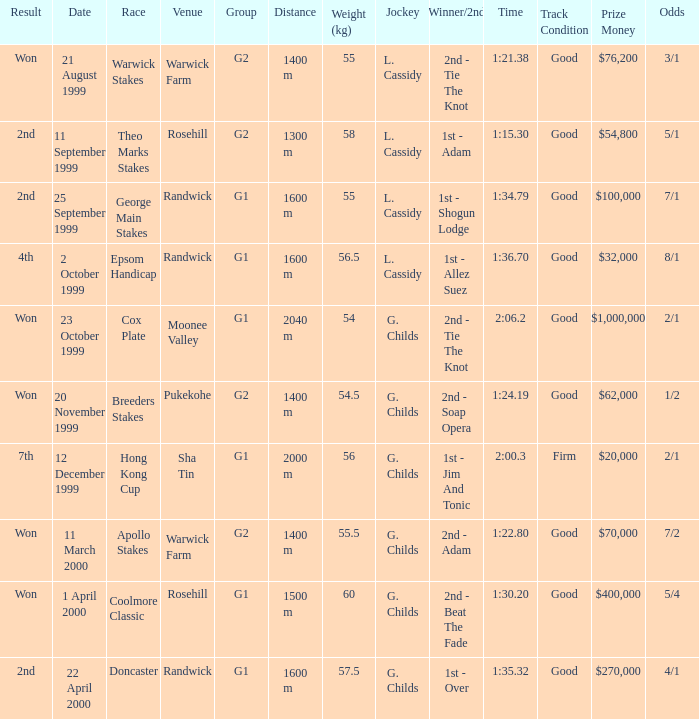List the weight for 56 kilograms. 2000 m. 